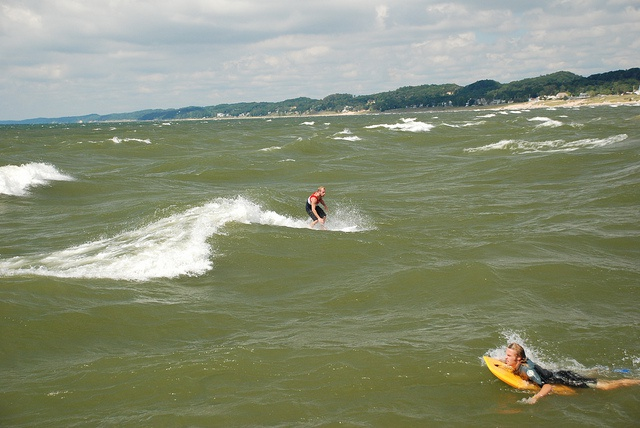Describe the objects in this image and their specific colors. I can see people in lightgray, black, gray, and tan tones, surfboard in lightgray, gold, olive, and orange tones, people in lightgray, black, gray, and tan tones, and surfboard in lightgray, white, gray, and olive tones in this image. 